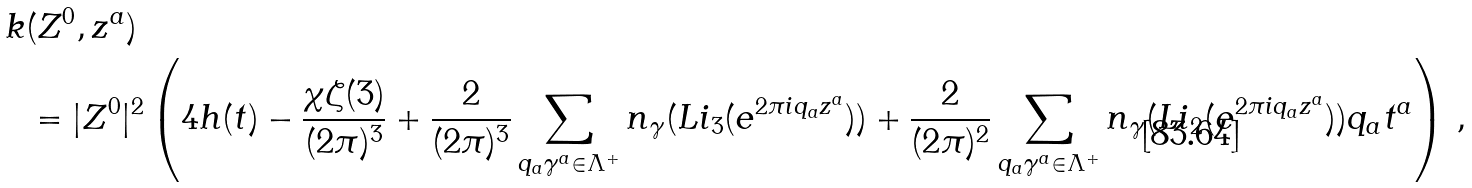Convert formula to latex. <formula><loc_0><loc_0><loc_500><loc_500>k & ( Z ^ { 0 } , z ^ { a } ) \\ & = | Z ^ { 0 } | ^ { 2 } \left ( 4 h ( t ) - \frac { \chi \zeta ( 3 ) } { ( 2 \pi ) ^ { 3 } } + \frac { 2 } { ( 2 \pi ) ^ { 3 } } \sum _ { q _ { a } \gamma ^ { a } \in \Lambda ^ { + } } n _ { \gamma } ( L i _ { 3 } ( e ^ { 2 \pi i q _ { a } z ^ { a } } ) ) + \frac { 2 } { ( 2 \pi ) ^ { 2 } } \sum _ { q _ { a } \gamma ^ { a } \in \Lambda ^ { + } } n _ { \gamma } ( L i _ { 2 } ( e ^ { 2 \pi i q _ { a } z ^ { a } } ) ) q _ { a } t ^ { a } \right ) \, , \\</formula> 